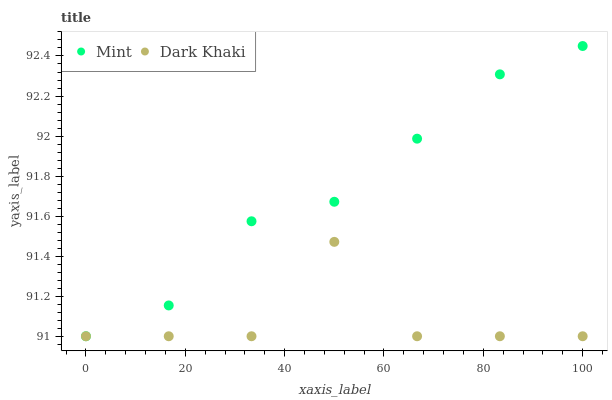Does Dark Khaki have the minimum area under the curve?
Answer yes or no. Yes. Does Mint have the maximum area under the curve?
Answer yes or no. Yes. Does Mint have the minimum area under the curve?
Answer yes or no. No. Is Mint the smoothest?
Answer yes or no. Yes. Is Dark Khaki the roughest?
Answer yes or no. Yes. Is Mint the roughest?
Answer yes or no. No. Does Dark Khaki have the lowest value?
Answer yes or no. Yes. Does Mint have the highest value?
Answer yes or no. Yes. Does Mint intersect Dark Khaki?
Answer yes or no. Yes. Is Mint less than Dark Khaki?
Answer yes or no. No. Is Mint greater than Dark Khaki?
Answer yes or no. No. 